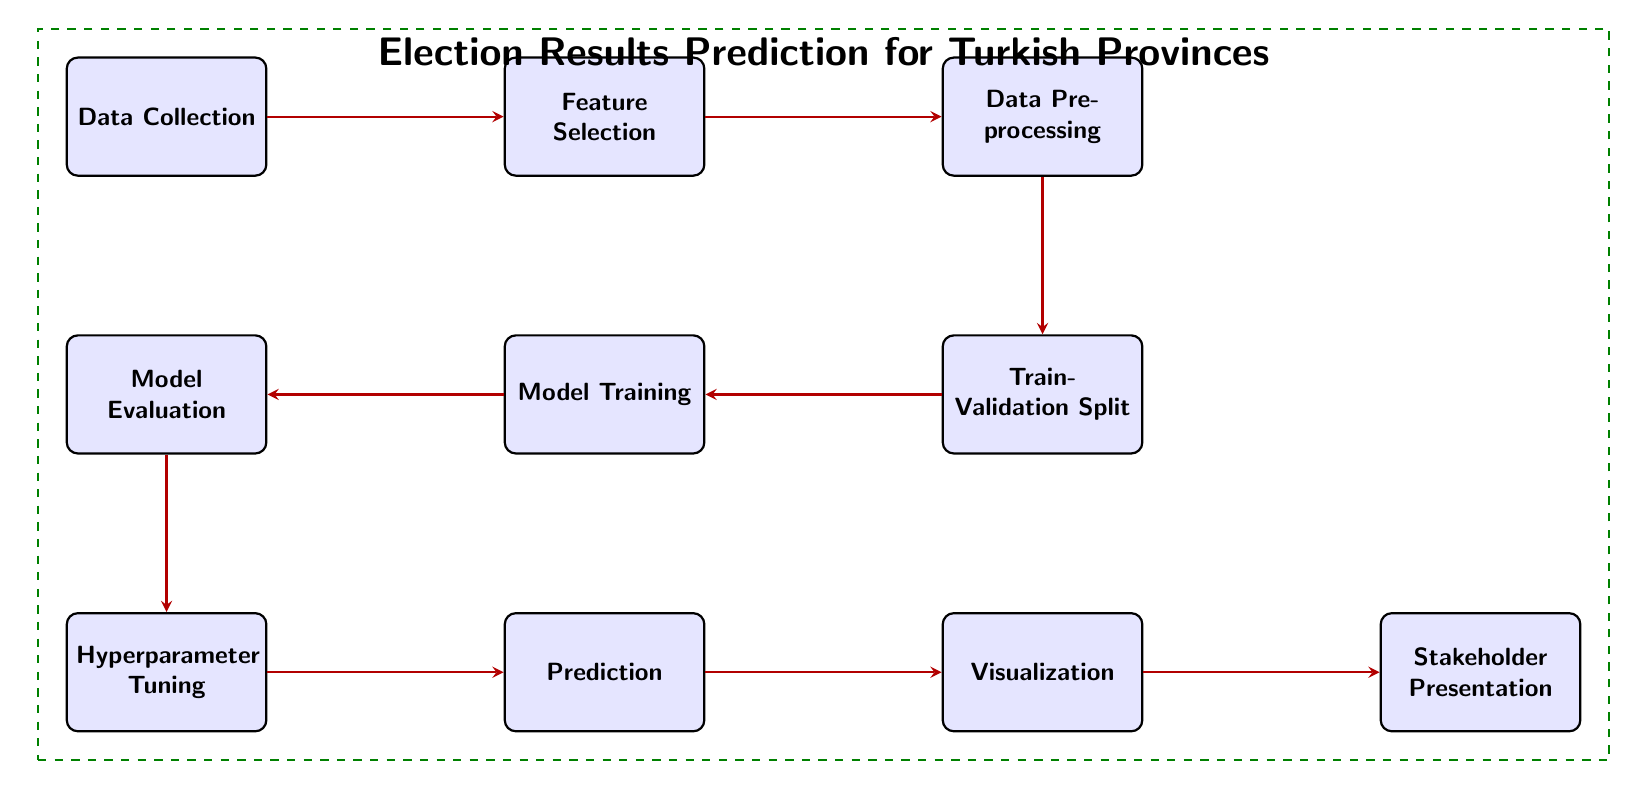What is the first node in the diagram? The first node in the diagram is labeled "Data Collection", which is the starting point of the process outlined in the diagram.
Answer: Data Collection How many nodes are there in total? By counting all the nodes presented in the diagram, there are a total of ten nodes outlining various stages of the election results prediction process.
Answer: Ten What is the last step in the process? The last step in the process, according to the diagram, is labeled "Stakeholder Presentation", which is the final output of the entire workflow.
Answer: Stakeholder Presentation Which node comes after "Hyperparameter Tuning"? In the flow outlined in the diagram, the node that comes directly after "Hyperparameter Tuning" is labeled "Prediction", indicating the step where predictions are made based on the trained model.
Answer: Prediction What is the relationship between "Model Evaluation" and "Model Training"? The relationship indicates a direct flow where "Model Training" precedes "Model Evaluation", meaning that model evaluation occurs after model training is completed, ensuring that the model's performance is assessed appropriately.
Answer: Model Training leads to Model Evaluation What is the function of the "Feature Selection" node? The "Feature Selection" node is responsible for choosing relevant features from the data that will be used in building the prediction model, thereby improving the model's performance and reducing complexity.
Answer: Selecting relevant features Which node acts as the main connection between Data Collection and Visualization? The main connection between "Data Collection" and "Visualization" is established through a series of nodes, with the process flowing from "Data Collection" to "Feature Selection", "Data Preprocessing", through "Train-Validation Split", "Model Training", "Model Evaluation", and "Hyperparameter Tuning" before finally leading to "Visualization".
Answer: Through multiple nodes How many arrows are present in the diagram? The diagram contains a total of nine arrows, each representing the flow from one process step to the next in the election results prediction.
Answer: Nine What indicates that this diagram is specifically for election results prediction in Turkish provinces? The title of the dashed box at the top of the diagram clearly states "Election Results Prediction for Turkish Provinces", indicating the specific application focus of the entire workflow depicted.
Answer: Title of the dashed box 